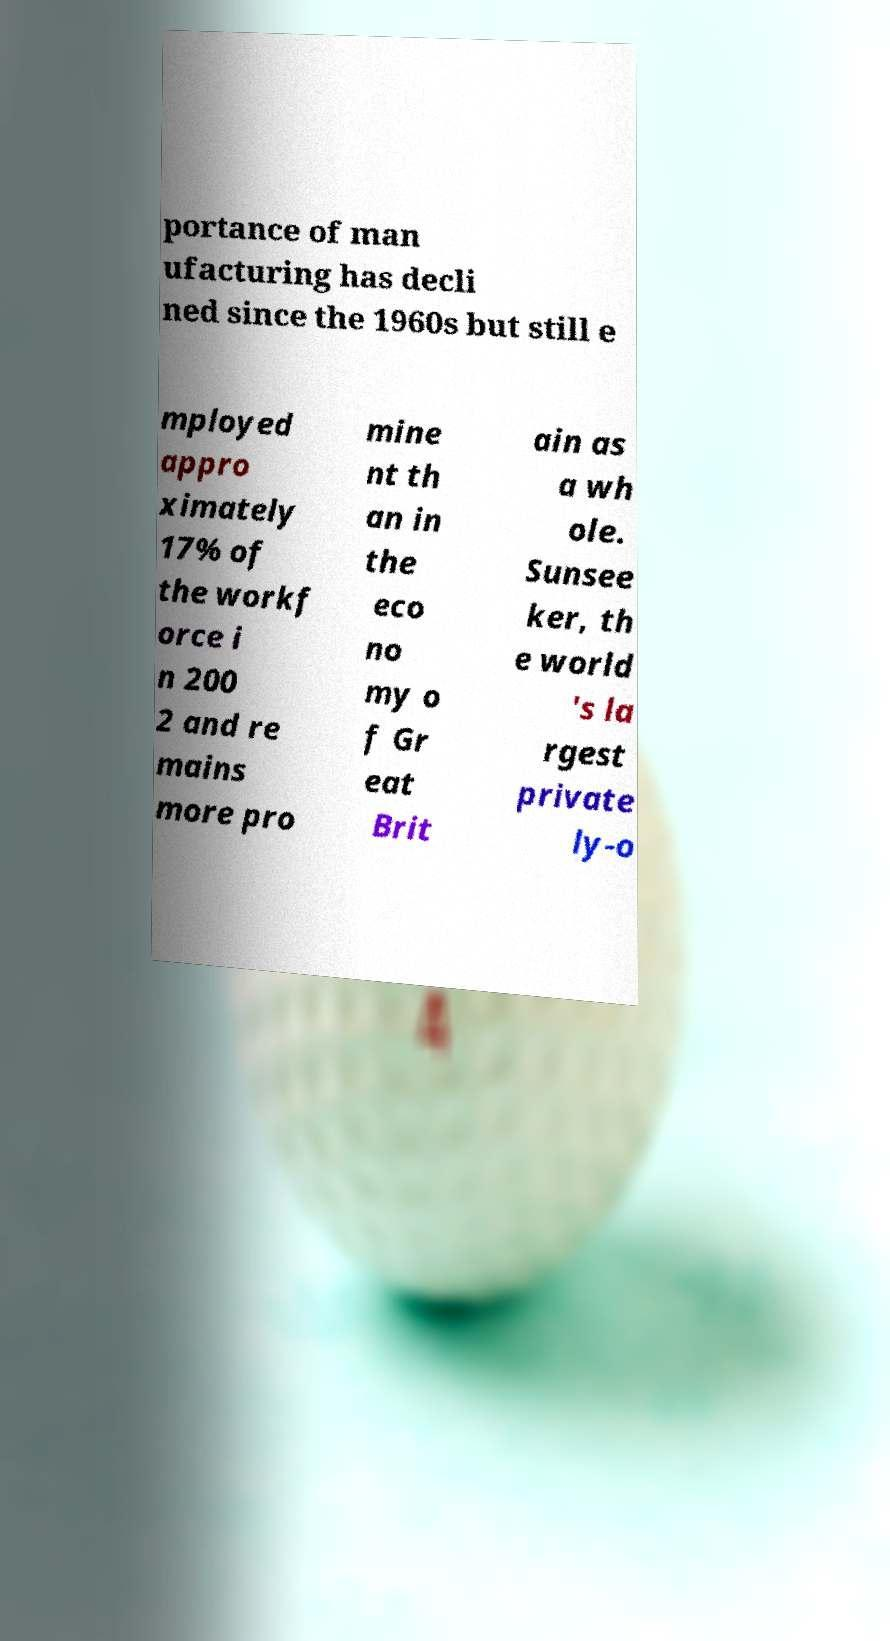What messages or text are displayed in this image? I need them in a readable, typed format. portance of man ufacturing has decli ned since the 1960s but still e mployed appro ximately 17% of the workf orce i n 200 2 and re mains more pro mine nt th an in the eco no my o f Gr eat Brit ain as a wh ole. Sunsee ker, th e world 's la rgest private ly-o 